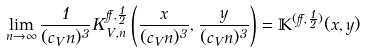<formula> <loc_0><loc_0><loc_500><loc_500>\lim _ { n \to \infty } \frac { 1 } { ( c _ { V } n ) ^ { 3 } } K ^ { \alpha , \frac { 1 } { 2 } } _ { V , n } \left ( \frac { x } { ( c _ { V } n ) ^ { 3 } } , \frac { y } { ( c _ { V } n ) ^ { 3 } } \right ) = \mathbb { K } ^ { ( \alpha , \frac { 1 } { 2 } ) } ( x , y )</formula> 